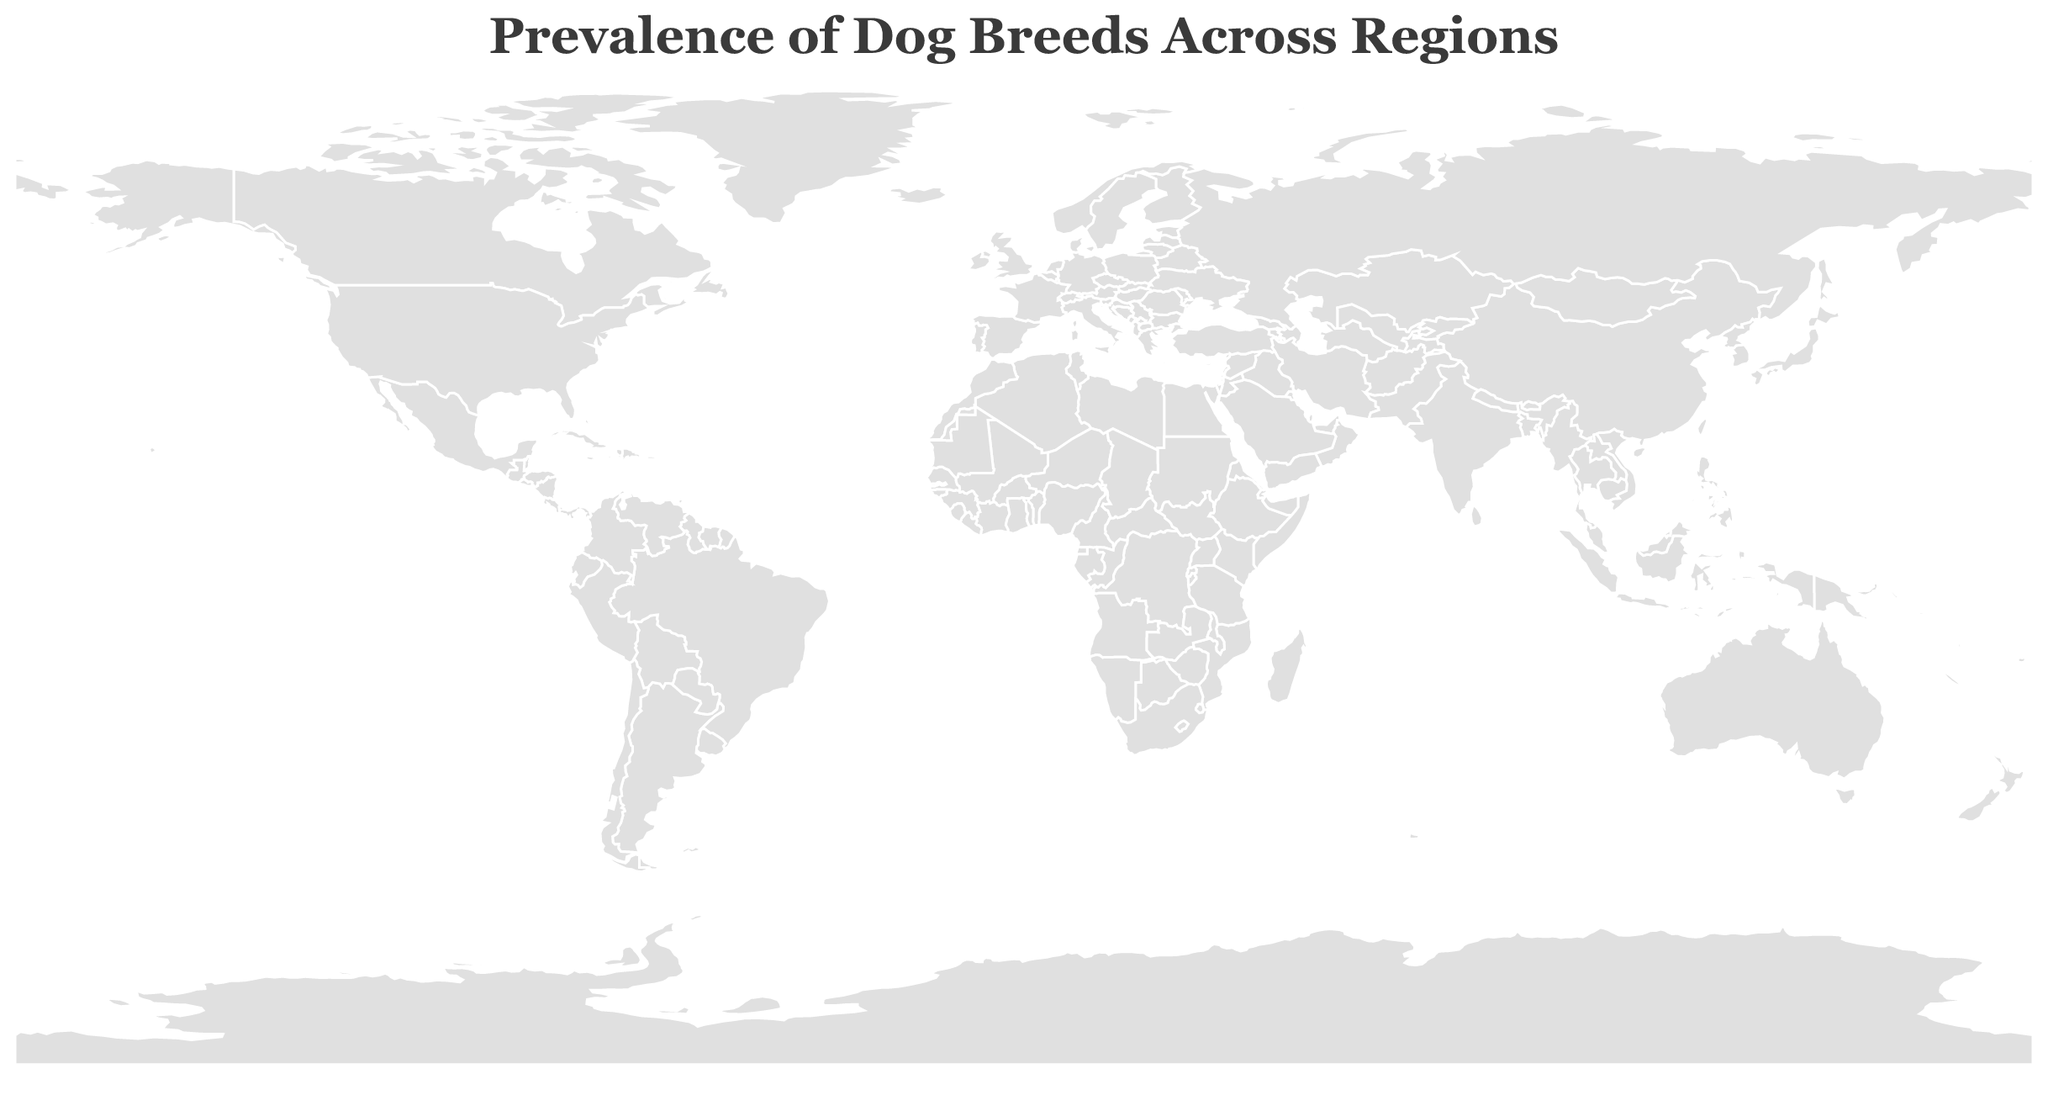What's the title of the figure? The title is placed at the top center of the figure and is clearly written in a larger font size, making it easily identifiable.
Answer: Prevalence of Dog Breeds Across Regions How many data points are represented in the figure? Each circle represents a data point; hence, counting the number of circles will give us the total number of data points. There are 15 circles in total.
Answer: 15 Which region has the highest prevalence of a dog breed, and what is the value? By observing the size of the circles and the corresponding tooltip information, the largest circle indicates the highest prevalence. The United States with the Labrador Retriever has the highest prevalence.
Answer: United States, 25.8 Compare the prevalence of the Golden Retriever in Australia to the German Shepherd in Germany. Which is higher? The prevalence values in the tooltip show that the Golden Retriever in Australia has a prevalence of 15.7, while the German Shepherd in Germany has a prevalence of 14.3.
Answer: Golden Retriever in Australia What's the combined prevalence of the Poodle in Canada and the Cavalier King Charles Spaniel in France? The tooltip provides the prevalence values: Poodle in Canada is 11.6 and Cavalier King Charles Spaniel in France is 10.4. Summing these values gives us the combined prevalence. 11.6 + 10.4 = 22
Answer: 22 Which breed has the lowest prevalence and in which region? By examining the tooltips and comparing the prevalence values, the lowest prevalence circle is the Rhodesian Ridgeback in South Africa with a prevalence of 5.3.
Answer: Rhodesian Ridgeback in South Africa Out of the breeds listed, which one has a prevalence value closest to 10, and in which region is it found? Checking the tooltips, the Cavalier King Charles Spaniel in France has a prevalence of 10.4, closest to 10.
Answer: Cavalier King Charles Spaniel in France How does the prevalence of the Boxer in Mexico compare to the Beagle in India? The tooltips show that the Boxer in Mexico has a prevalence of 5.7, while the Beagle in India has a prevalence of 6.1. The Boxer has a lower prevalence.
Answer: Boxer in Mexico is less than Beagle in India By how much does the prevalence of the Chihuahua in Italy differ from the prevalence of the Yorkshire Terrier in Spain? From the tooltips, the prevalence of the Chihuahua in Italy is 9.8 and the Yorkshire Terrier in Spain is 8.5. The difference is calculated as 9.8 - 8.5 = 1.3.
Answer: 1.3 